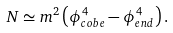Convert formula to latex. <formula><loc_0><loc_0><loc_500><loc_500>N \simeq m ^ { 2 } \left ( \phi _ { c o b e } ^ { 4 } - \phi _ { e n d } ^ { 4 } \right ) .</formula> 